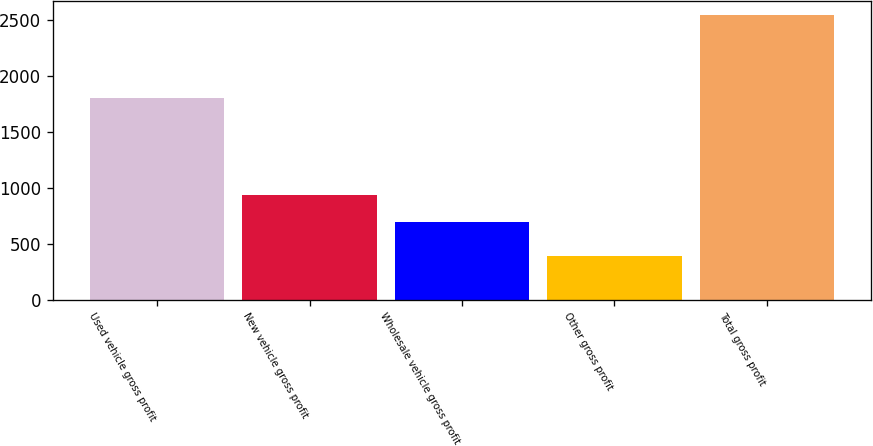<chart> <loc_0><loc_0><loc_500><loc_500><bar_chart><fcel>Used vehicle gross profit<fcel>New vehicle gross profit<fcel>Wholesale vehicle gross profit<fcel>Other gross profit<fcel>Total gross profit<nl><fcel>1808<fcel>934<fcel>700<fcel>391<fcel>2544<nl></chart> 